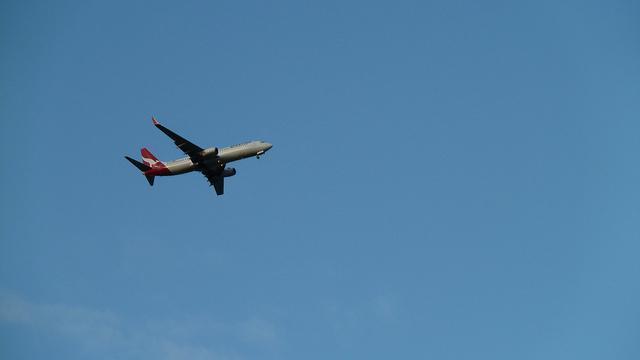How many engines on the wings?
Give a very brief answer. 2. 